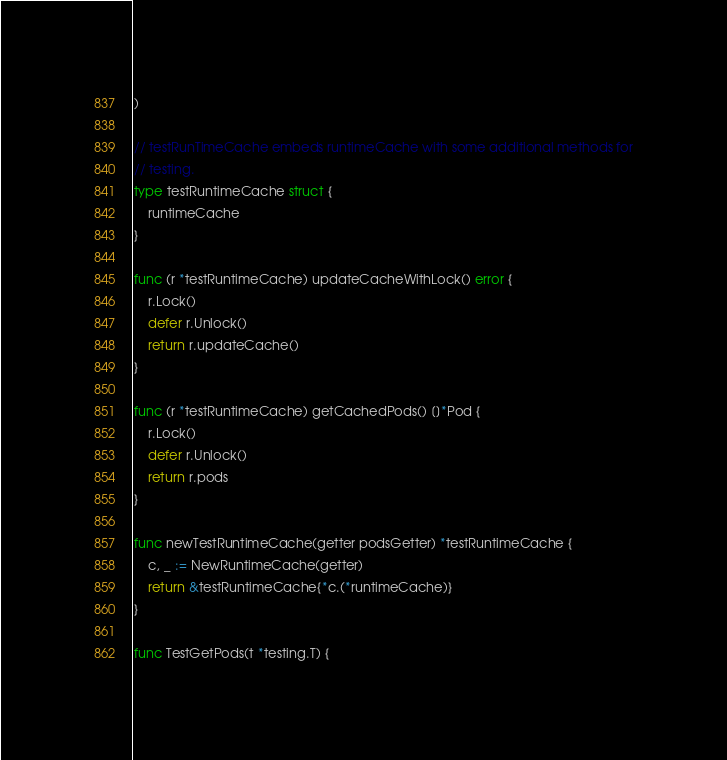Convert code to text. <code><loc_0><loc_0><loc_500><loc_500><_Go_>)

// testRunTimeCache embeds runtimeCache with some additional methods for
// testing.
type testRuntimeCache struct {
	runtimeCache
}

func (r *testRuntimeCache) updateCacheWithLock() error {
	r.Lock()
	defer r.Unlock()
	return r.updateCache()
}

func (r *testRuntimeCache) getCachedPods() []*Pod {
	r.Lock()
	defer r.Unlock()
	return r.pods
}

func newTestRuntimeCache(getter podsGetter) *testRuntimeCache {
	c, _ := NewRuntimeCache(getter)
	return &testRuntimeCache{*c.(*runtimeCache)}
}

func TestGetPods(t *testing.T) {</code> 